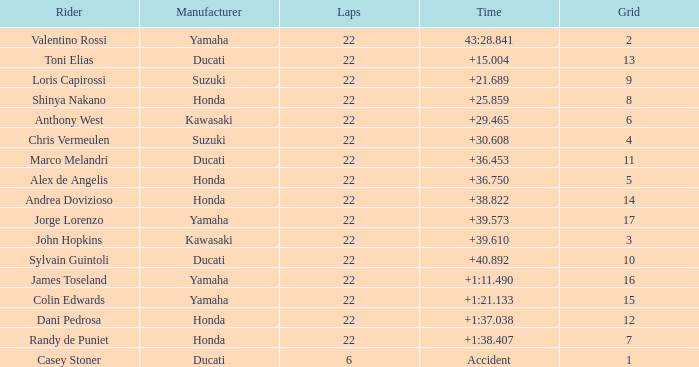Who had the lowest laps on a grid smaller than 16 with a time of +21.689? 22.0. Could you parse the entire table as a dict? {'header': ['Rider', 'Manufacturer', 'Laps', 'Time', 'Grid'], 'rows': [['Valentino Rossi', 'Yamaha', '22', '43:28.841', '2'], ['Toni Elias', 'Ducati', '22', '+15.004', '13'], ['Loris Capirossi', 'Suzuki', '22', '+21.689', '9'], ['Shinya Nakano', 'Honda', '22', '+25.859', '8'], ['Anthony West', 'Kawasaki', '22', '+29.465', '6'], ['Chris Vermeulen', 'Suzuki', '22', '+30.608', '4'], ['Marco Melandri', 'Ducati', '22', '+36.453', '11'], ['Alex de Angelis', 'Honda', '22', '+36.750', '5'], ['Andrea Dovizioso', 'Honda', '22', '+38.822', '14'], ['Jorge Lorenzo', 'Yamaha', '22', '+39.573', '17'], ['John Hopkins', 'Kawasaki', '22', '+39.610', '3'], ['Sylvain Guintoli', 'Ducati', '22', '+40.892', '10'], ['James Toseland', 'Yamaha', '22', '+1:11.490', '16'], ['Colin Edwards', 'Yamaha', '22', '+1:21.133', '15'], ['Dani Pedrosa', 'Honda', '22', '+1:37.038', '12'], ['Randy de Puniet', 'Honda', '22', '+1:38.407', '7'], ['Casey Stoner', 'Ducati', '6', 'Accident', '1']]} 